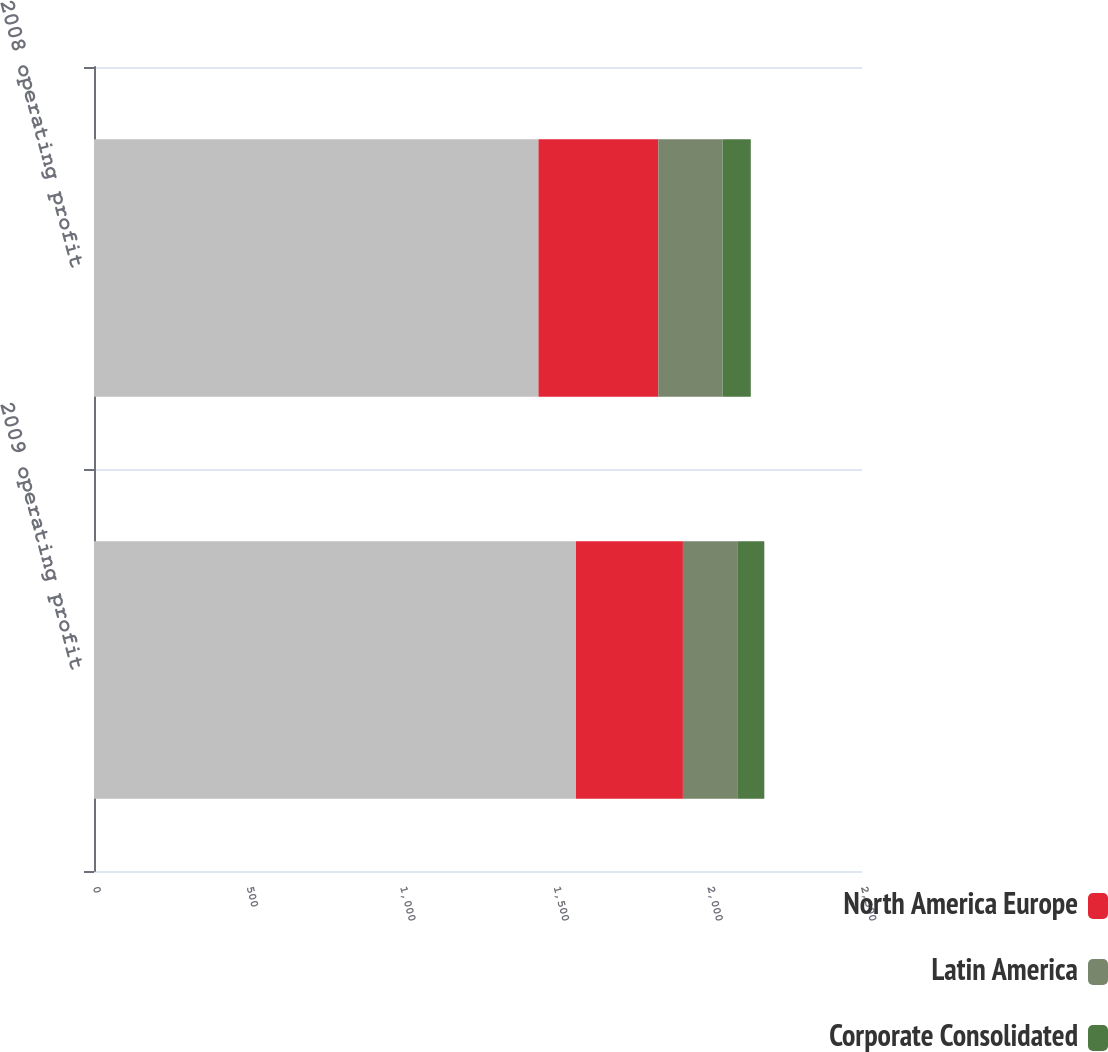<chart> <loc_0><loc_0><loc_500><loc_500><stacked_bar_chart><ecel><fcel>2009 operating profit<fcel>2008 operating profit<nl><fcel>nan<fcel>1569<fcel>1447<nl><fcel>North America Europe<fcel>348<fcel>390<nl><fcel>Latin America<fcel>179<fcel>209<nl><fcel>Corporate Consolidated<fcel>86<fcel>92<nl></chart> 